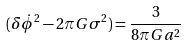<formula> <loc_0><loc_0><loc_500><loc_500>( { \delta } { \dot { \phi } } ^ { 2 } - 2 { \pi } G { \sigma } ^ { 2 } ) = \frac { 3 } { 8 { \pi } G a ^ { 2 } }</formula> 